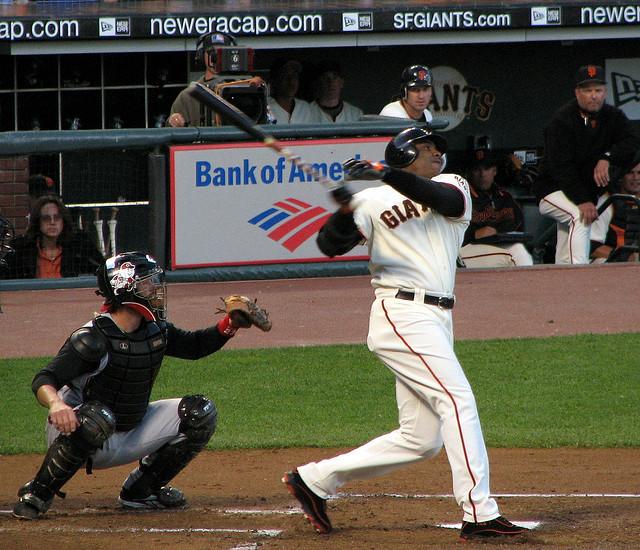Who is winning?
Give a very brief answer. Giants. What team is playing?
Give a very brief answer. Giants. What does the sign in the background say?
Keep it brief. Bank of america. 